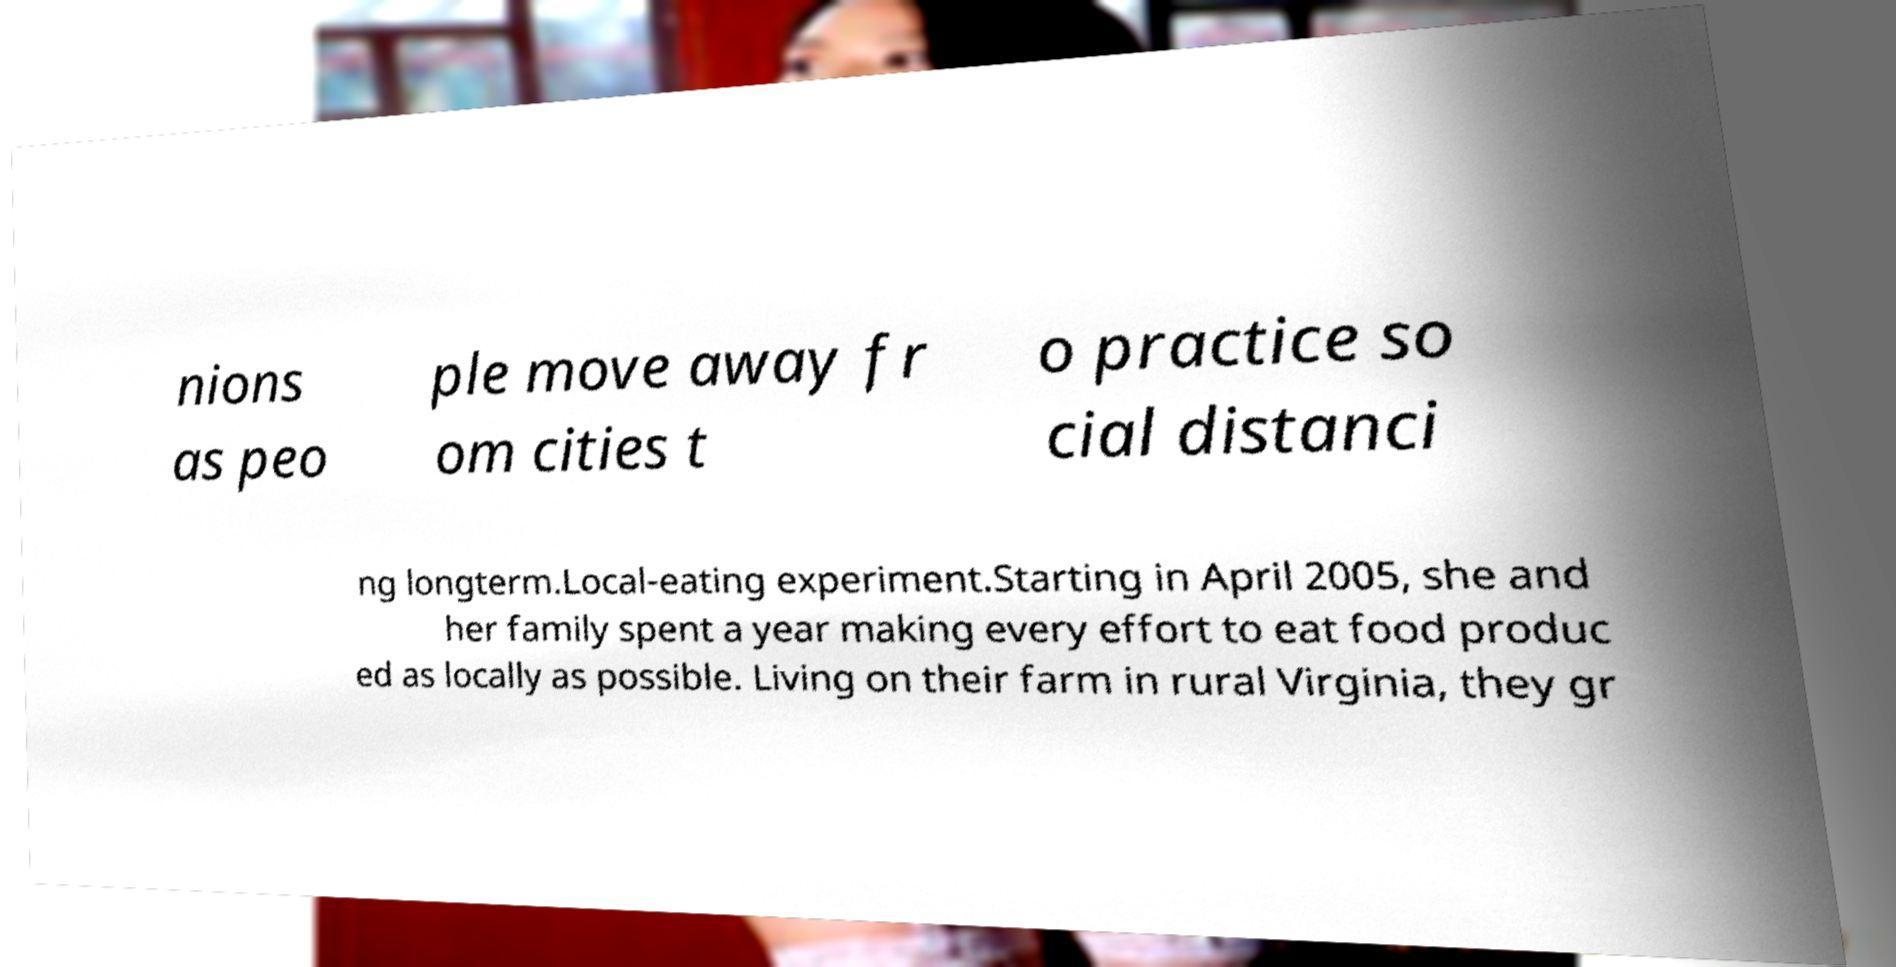For documentation purposes, I need the text within this image transcribed. Could you provide that? nions as peo ple move away fr om cities t o practice so cial distanci ng longterm.Local-eating experiment.Starting in April 2005, she and her family spent a year making every effort to eat food produc ed as locally as possible. Living on their farm in rural Virginia, they gr 